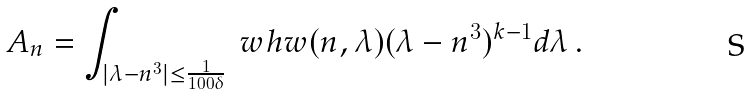<formula> <loc_0><loc_0><loc_500><loc_500>A _ { n } = \int _ { | \lambda - n ^ { 3 } | \leq \frac { 1 } { 1 0 0 \delta } } \ w h w ( n , \lambda ) ( \lambda - n ^ { 3 } ) ^ { k - 1 } d \lambda \, .</formula> 